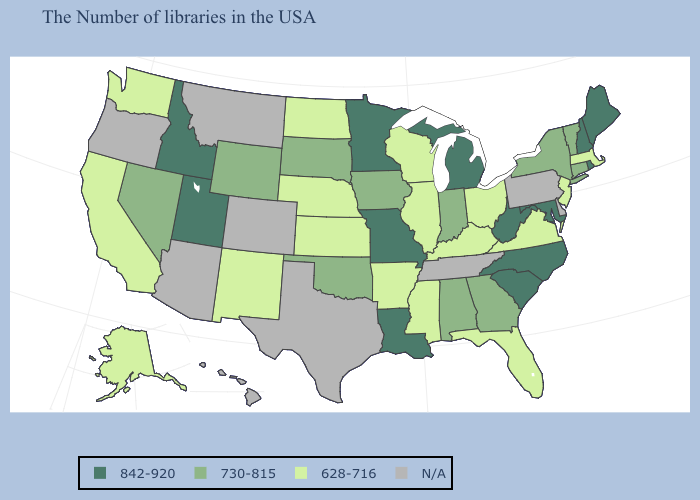Does the map have missing data?
Quick response, please. Yes. What is the lowest value in the West?
Write a very short answer. 628-716. Among the states that border Tennessee , does North Carolina have the lowest value?
Short answer required. No. Name the states that have a value in the range N/A?
Concise answer only. Delaware, Pennsylvania, Tennessee, Texas, Colorado, Montana, Arizona, Oregon, Hawaii. Does Indiana have the lowest value in the MidWest?
Concise answer only. No. What is the highest value in the USA?
Keep it brief. 842-920. Name the states that have a value in the range N/A?
Keep it brief. Delaware, Pennsylvania, Tennessee, Texas, Colorado, Montana, Arizona, Oregon, Hawaii. Among the states that border Colorado , does Wyoming have the highest value?
Concise answer only. No. Name the states that have a value in the range N/A?
Quick response, please. Delaware, Pennsylvania, Tennessee, Texas, Colorado, Montana, Arizona, Oregon, Hawaii. Among the states that border Oregon , which have the highest value?
Keep it brief. Idaho. What is the highest value in the West ?
Give a very brief answer. 842-920. Name the states that have a value in the range N/A?
Be succinct. Delaware, Pennsylvania, Tennessee, Texas, Colorado, Montana, Arizona, Oregon, Hawaii. Is the legend a continuous bar?
Answer briefly. No. 